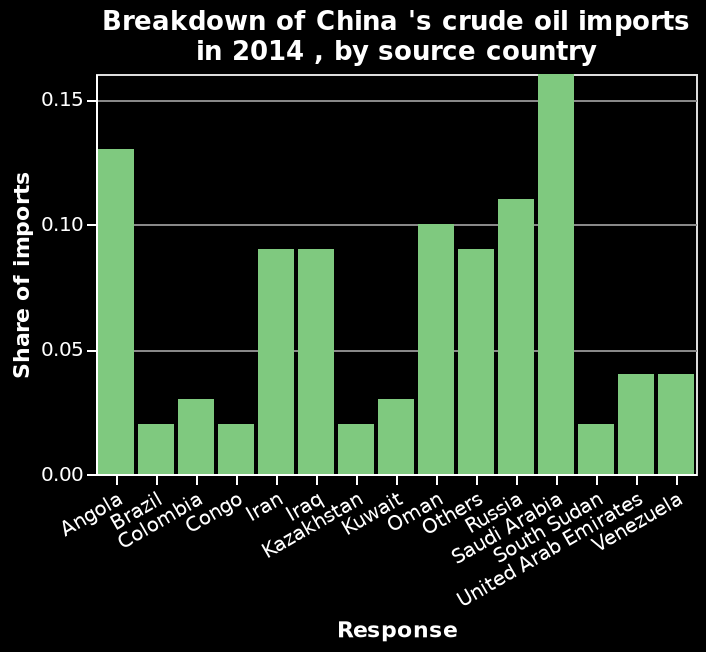<image>
please summary the statistics and relations of the chart Most of China's crude oil imports go to South Arabia. Least of imports go to Brazil, Kongo, Kazakshtan and South Sudan. The top 3 countries for crude oil import from China are South Arabia, Angola and Russia. There are no European countries (unless they are included in the category 'Others'). Are there any European countries among China's top crude oil importers? No, unless they are included in the category 'Others'. What are the top 3 countries for crude oil import from China? South Arabia, Angola, and Russia Which countries receive the least crude oil imports from China? Brazil, Kongo, Kazakshtan, and South Sudan Are most of China's crude oil imports going to South Sudan? No.Most of China's crude oil imports go to South Arabia. Least of imports go to Brazil, Kongo, Kazakshtan and South Sudan. The top 3 countries for crude oil import from China are South Arabia, Angola and Russia. There are no European countries (unless they are included in the category 'Others'). 